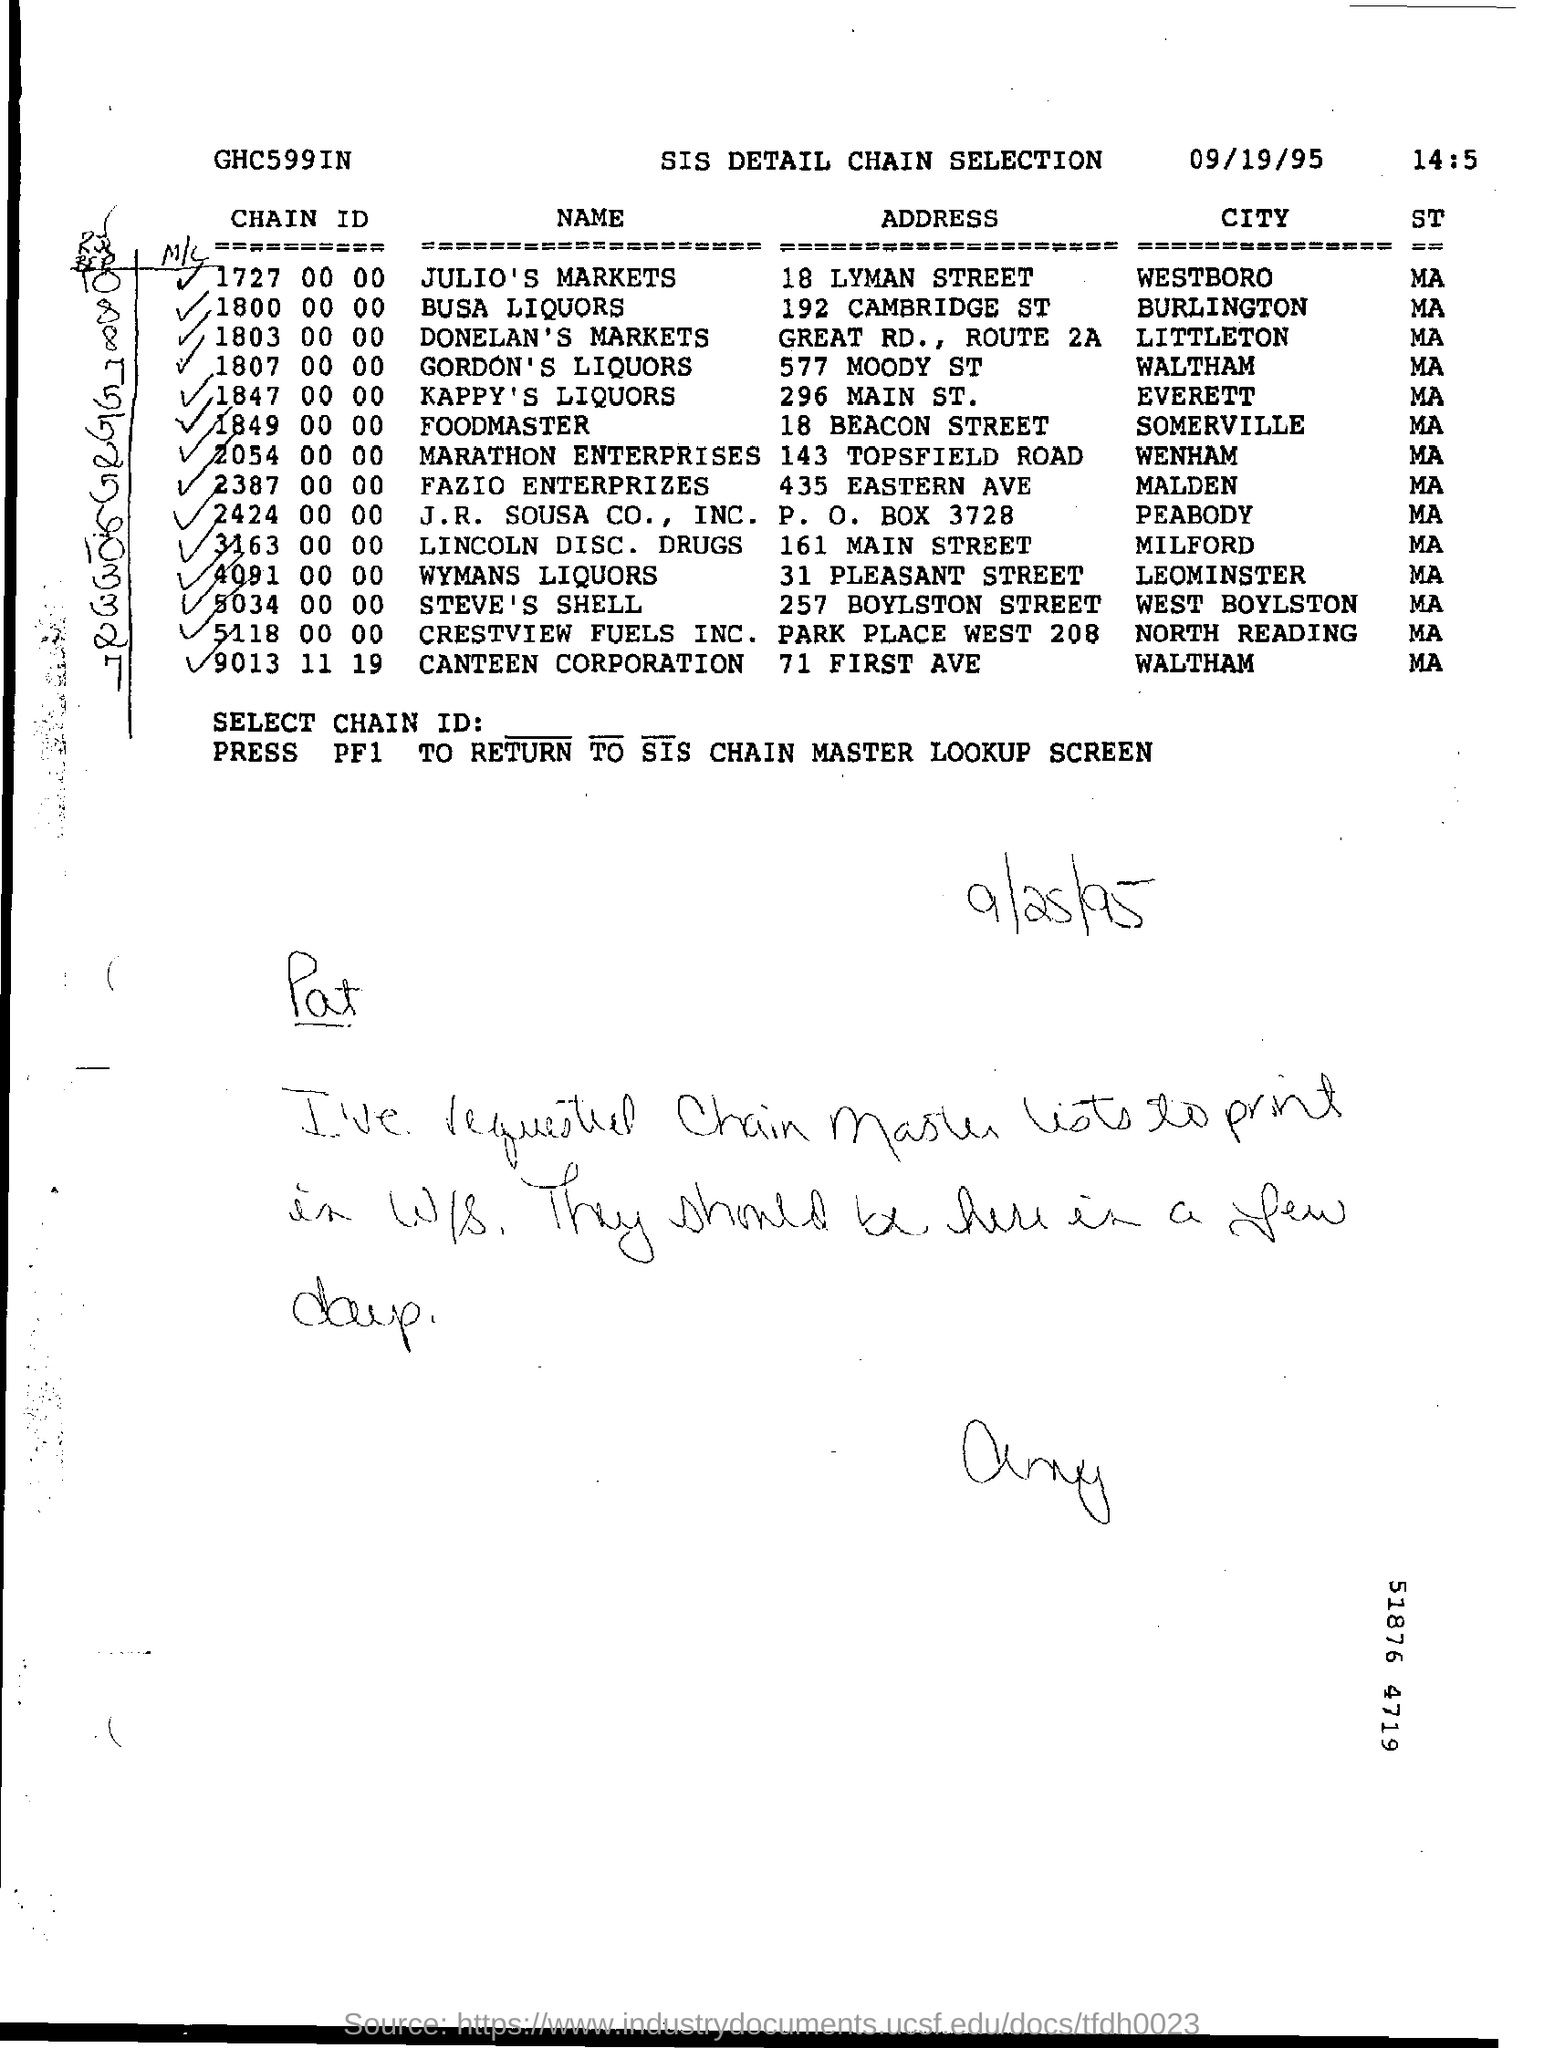Mention a couple of crucial points in this snapshot. The month mentioned in the chain selection is 09.. The chain ID for which address and city is 9013 11 19. The address is 71 FIRST AVE in WALTHAM. 